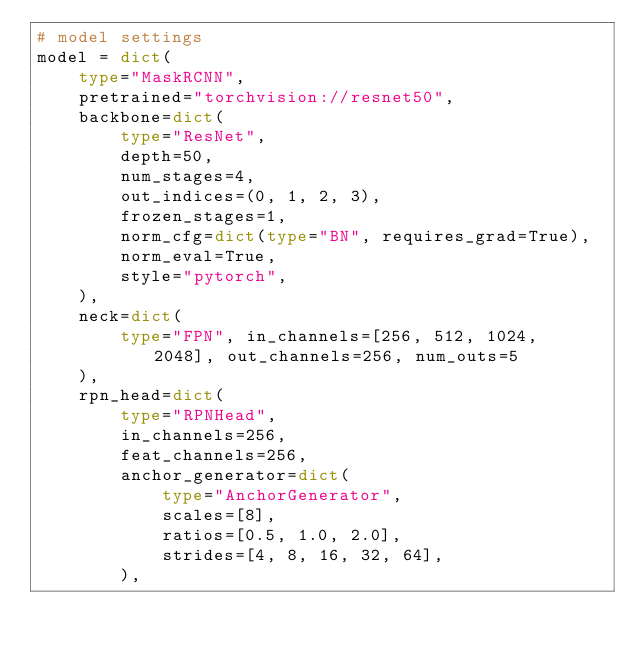Convert code to text. <code><loc_0><loc_0><loc_500><loc_500><_Python_># model settings
model = dict(
    type="MaskRCNN",
    pretrained="torchvision://resnet50",
    backbone=dict(
        type="ResNet",
        depth=50,
        num_stages=4,
        out_indices=(0, 1, 2, 3),
        frozen_stages=1,
        norm_cfg=dict(type="BN", requires_grad=True),
        norm_eval=True,
        style="pytorch",
    ),
    neck=dict(
        type="FPN", in_channels=[256, 512, 1024, 2048], out_channels=256, num_outs=5
    ),
    rpn_head=dict(
        type="RPNHead",
        in_channels=256,
        feat_channels=256,
        anchor_generator=dict(
            type="AnchorGenerator",
            scales=[8],
            ratios=[0.5, 1.0, 2.0],
            strides=[4, 8, 16, 32, 64],
        ),</code> 